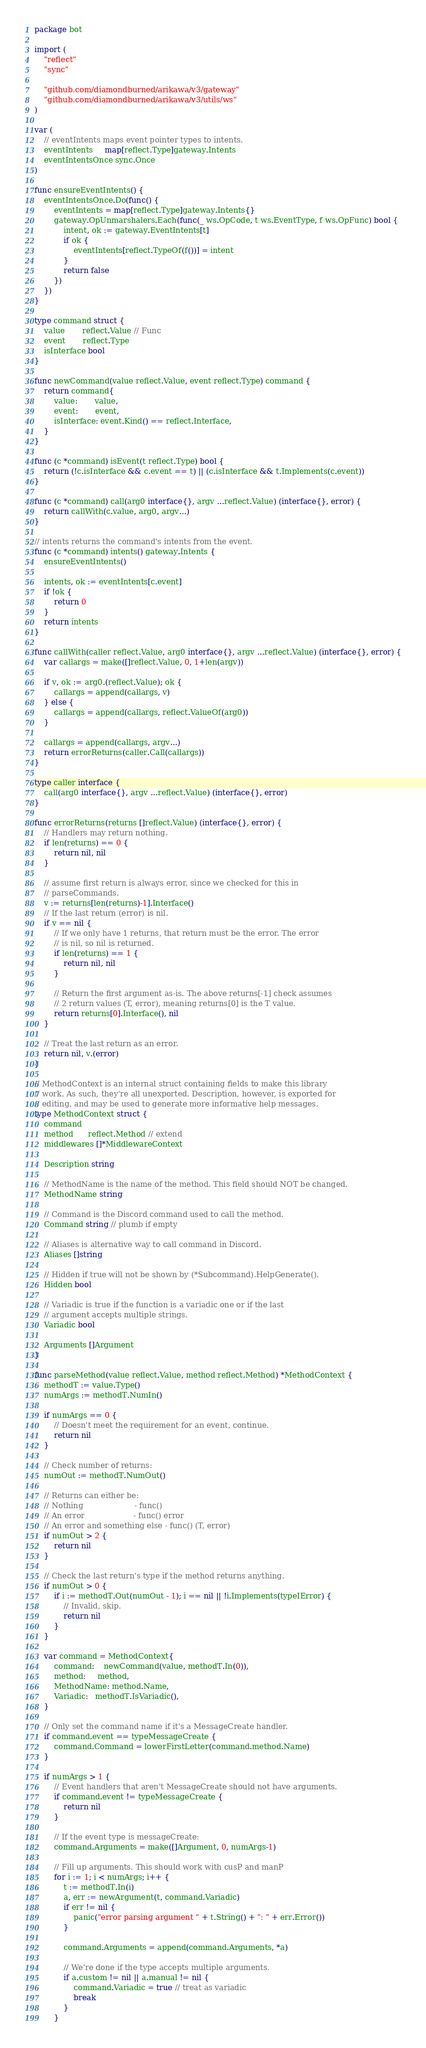<code> <loc_0><loc_0><loc_500><loc_500><_Go_>package bot

import (
	"reflect"
	"sync"

	"github.com/diamondburned/arikawa/v3/gateway"
	"github.com/diamondburned/arikawa/v3/utils/ws"
)

var (
	// eventIntents maps event pointer types to intents.
	eventIntents     map[reflect.Type]gateway.Intents
	eventIntentsOnce sync.Once
)

func ensureEventIntents() {
	eventIntentsOnce.Do(func() {
		eventIntents = map[reflect.Type]gateway.Intents{}
		gateway.OpUnmarshalers.Each(func(_ ws.OpCode, t ws.EventType, f ws.OpFunc) bool {
			intent, ok := gateway.EventIntents[t]
			if ok {
				eventIntents[reflect.TypeOf(f())] = intent
			}
			return false
		})
	})
}

type command struct {
	value       reflect.Value // Func
	event       reflect.Type
	isInterface bool
}

func newCommand(value reflect.Value, event reflect.Type) command {
	return command{
		value:       value,
		event:       event,
		isInterface: event.Kind() == reflect.Interface,
	}
}

func (c *command) isEvent(t reflect.Type) bool {
	return (!c.isInterface && c.event == t) || (c.isInterface && t.Implements(c.event))
}

func (c *command) call(arg0 interface{}, argv ...reflect.Value) (interface{}, error) {
	return callWith(c.value, arg0, argv...)
}

// intents returns the command's intents from the event.
func (c *command) intents() gateway.Intents {
	ensureEventIntents()

	intents, ok := eventIntents[c.event]
	if !ok {
		return 0
	}
	return intents
}

func callWith(caller reflect.Value, arg0 interface{}, argv ...reflect.Value) (interface{}, error) {
	var callargs = make([]reflect.Value, 0, 1+len(argv))

	if v, ok := arg0.(reflect.Value); ok {
		callargs = append(callargs, v)
	} else {
		callargs = append(callargs, reflect.ValueOf(arg0))
	}

	callargs = append(callargs, argv...)
	return errorReturns(caller.Call(callargs))
}

type caller interface {
	call(arg0 interface{}, argv ...reflect.Value) (interface{}, error)
}

func errorReturns(returns []reflect.Value) (interface{}, error) {
	// Handlers may return nothing.
	if len(returns) == 0 {
		return nil, nil
	}

	// assume first return is always error, since we checked for this in
	// parseCommands.
	v := returns[len(returns)-1].Interface()
	// If the last return (error) is nil.
	if v == nil {
		// If we only have 1 returns, that return must be the error. The error
		// is nil, so nil is returned.
		if len(returns) == 1 {
			return nil, nil
		}

		// Return the first argument as-is. The above returns[-1] check assumes
		// 2 return values (T, error), meaning returns[0] is the T value.
		return returns[0].Interface(), nil
	}

	// Treat the last return as an error.
	return nil, v.(error)
}

// MethodContext is an internal struct containing fields to make this library
// work. As such, they're all unexported. Description, however, is exported for
// editing, and may be used to generate more informative help messages.
type MethodContext struct {
	command
	method      reflect.Method // extend
	middlewares []*MiddlewareContext

	Description string

	// MethodName is the name of the method. This field should NOT be changed.
	MethodName string

	// Command is the Discord command used to call the method.
	Command string // plumb if empty

	// Aliases is alternative way to call command in Discord.
	Aliases []string

	// Hidden if true will not be shown by (*Subcommand).HelpGenerate().
	Hidden bool

	// Variadic is true if the function is a variadic one or if the last
	// argument accepts multiple strings.
	Variadic bool

	Arguments []Argument
}

func parseMethod(value reflect.Value, method reflect.Method) *MethodContext {
	methodT := value.Type()
	numArgs := methodT.NumIn()

	if numArgs == 0 {
		// Doesn't meet the requirement for an event, continue.
		return nil
	}

	// Check number of returns:
	numOut := methodT.NumOut()

	// Returns can either be:
	// Nothing                     - func()
	// An error                    - func() error
	// An error and something else - func() (T, error)
	if numOut > 2 {
		return nil
	}

	// Check the last return's type if the method returns anything.
	if numOut > 0 {
		if i := methodT.Out(numOut - 1); i == nil || !i.Implements(typeIError) {
			// Invalid, skip.
			return nil
		}
	}

	var command = MethodContext{
		command:    newCommand(value, methodT.In(0)),
		method:     method,
		MethodName: method.Name,
		Variadic:   methodT.IsVariadic(),
	}

	// Only set the command name if it's a MessageCreate handler.
	if command.event == typeMessageCreate {
		command.Command = lowerFirstLetter(command.method.Name)
	}

	if numArgs > 1 {
		// Event handlers that aren't MessageCreate should not have arguments.
		if command.event != typeMessageCreate {
			return nil
		}

		// If the event type is messageCreate:
		command.Arguments = make([]Argument, 0, numArgs-1)

		// Fill up arguments. This should work with cusP and manP
		for i := 1; i < numArgs; i++ {
			t := methodT.In(i)
			a, err := newArgument(t, command.Variadic)
			if err != nil {
				panic("error parsing argument " + t.String() + ": " + err.Error())
			}

			command.Arguments = append(command.Arguments, *a)

			// We're done if the type accepts multiple arguments.
			if a.custom != nil || a.manual != nil {
				command.Variadic = true // treat as variadic
				break
			}
		}</code> 